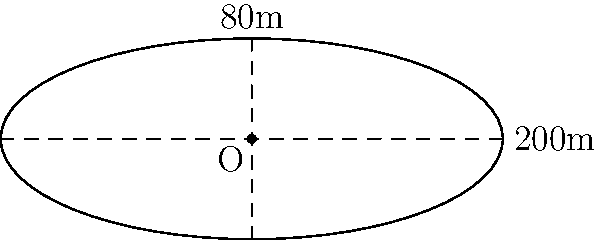An Olympic-standard running track is shaped like an oval, as shown in the diagram. The length of the track is 200 meters, and its width is 80 meters. Assuming the track can be approximated as an ellipse, calculate its area in square meters. Round your answer to the nearest whole number. To find the area of the oval-shaped running track, we'll use the formula for the area of an ellipse:

$$A = \pi ab$$

Where:
$A$ is the area
$a$ is half the length of the major axis (length)
$b$ is half the length of the minor axis (width)

Given:
- Length = 200 meters
- Width = 80 meters

Step 1: Calculate $a$ and $b$
$a = 200 \div 2 = 100$ meters
$b = 80 \div 2 = 40$ meters

Step 2: Apply the formula
$$A = \pi ab$$
$$A = \pi \times 100 \times 40$$

Step 3: Calculate the result
$$A = 4000\pi \approx 12,566.37 \text{ square meters}$$

Step 4: Round to the nearest whole number
$$A \approx 12,566 \text{ square meters}$$
Answer: 12,566 square meters 